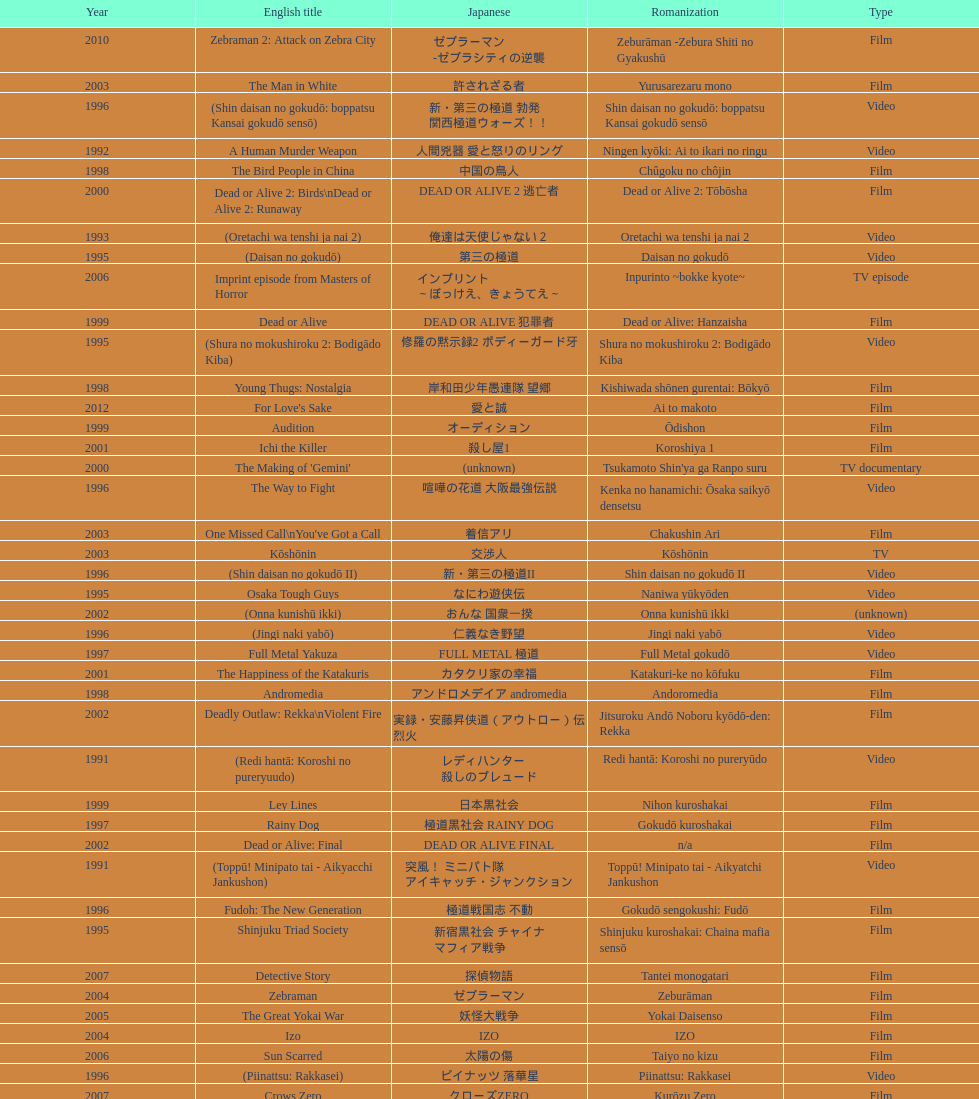Did shinjuku triad society come out as a film or a tv series? Film. 